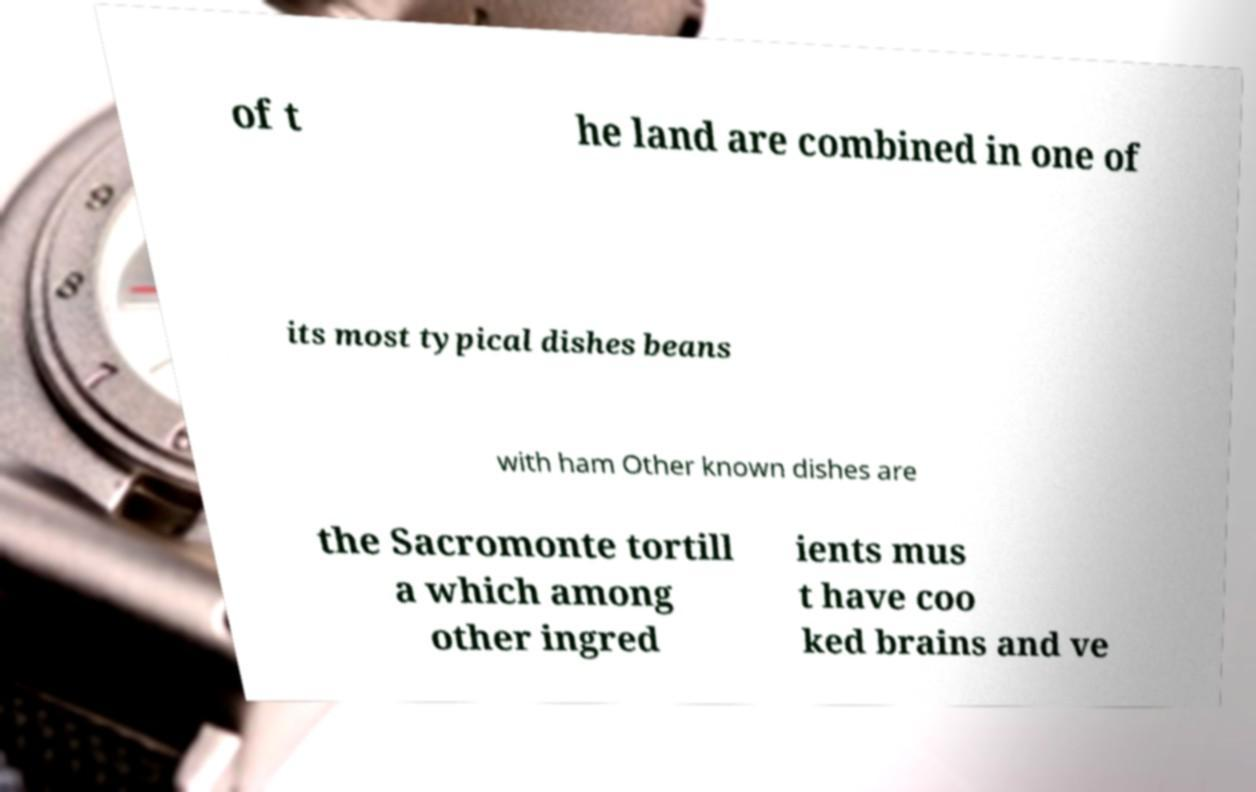Could you extract and type out the text from this image? of t he land are combined in one of its most typical dishes beans with ham Other known dishes are the Sacromonte tortill a which among other ingred ients mus t have coo ked brains and ve 